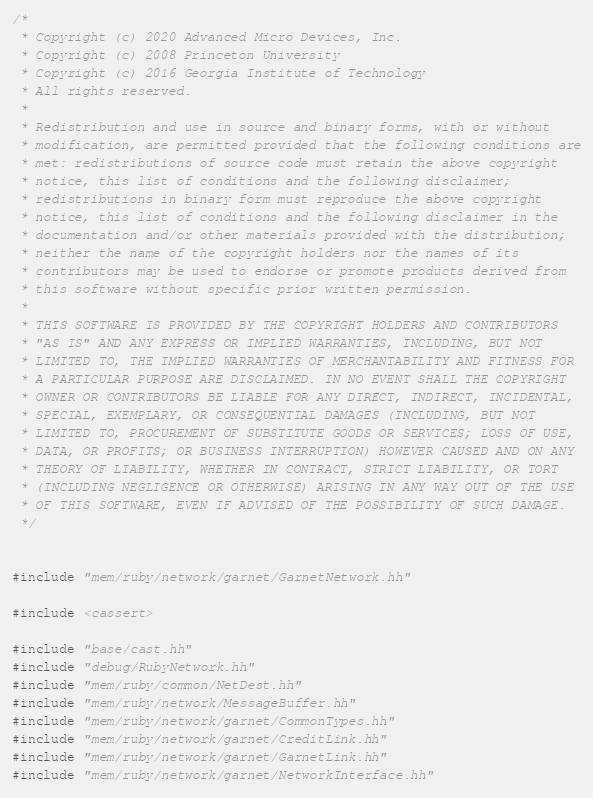Convert code to text. <code><loc_0><loc_0><loc_500><loc_500><_C++_>/*
 * Copyright (c) 2020 Advanced Micro Devices, Inc.
 * Copyright (c) 2008 Princeton University
 * Copyright (c) 2016 Georgia Institute of Technology
 * All rights reserved.
 *
 * Redistribution and use in source and binary forms, with or without
 * modification, are permitted provided that the following conditions are
 * met: redistributions of source code must retain the above copyright
 * notice, this list of conditions and the following disclaimer;
 * redistributions in binary form must reproduce the above copyright
 * notice, this list of conditions and the following disclaimer in the
 * documentation and/or other materials provided with the distribution;
 * neither the name of the copyright holders nor the names of its
 * contributors may be used to endorse or promote products derived from
 * this software without specific prior written permission.
 *
 * THIS SOFTWARE IS PROVIDED BY THE COPYRIGHT HOLDERS AND CONTRIBUTORS
 * "AS IS" AND ANY EXPRESS OR IMPLIED WARRANTIES, INCLUDING, BUT NOT
 * LIMITED TO, THE IMPLIED WARRANTIES OF MERCHANTABILITY AND FITNESS FOR
 * A PARTICULAR PURPOSE ARE DISCLAIMED. IN NO EVENT SHALL THE COPYRIGHT
 * OWNER OR CONTRIBUTORS BE LIABLE FOR ANY DIRECT, INDIRECT, INCIDENTAL,
 * SPECIAL, EXEMPLARY, OR CONSEQUENTIAL DAMAGES (INCLUDING, BUT NOT
 * LIMITED TO, PROCUREMENT OF SUBSTITUTE GOODS OR SERVICES; LOSS OF USE,
 * DATA, OR PROFITS; OR BUSINESS INTERRUPTION) HOWEVER CAUSED AND ON ANY
 * THEORY OF LIABILITY, WHETHER IN CONTRACT, STRICT LIABILITY, OR TORT
 * (INCLUDING NEGLIGENCE OR OTHERWISE) ARISING IN ANY WAY OUT OF THE USE
 * OF THIS SOFTWARE, EVEN IF ADVISED OF THE POSSIBILITY OF SUCH DAMAGE.
 */


#include "mem/ruby/network/garnet/GarnetNetwork.hh"

#include <cassert>

#include "base/cast.hh"
#include "debug/RubyNetwork.hh"
#include "mem/ruby/common/NetDest.hh"
#include "mem/ruby/network/MessageBuffer.hh"
#include "mem/ruby/network/garnet/CommonTypes.hh"
#include "mem/ruby/network/garnet/CreditLink.hh"
#include "mem/ruby/network/garnet/GarnetLink.hh"
#include "mem/ruby/network/garnet/NetworkInterface.hh"</code> 